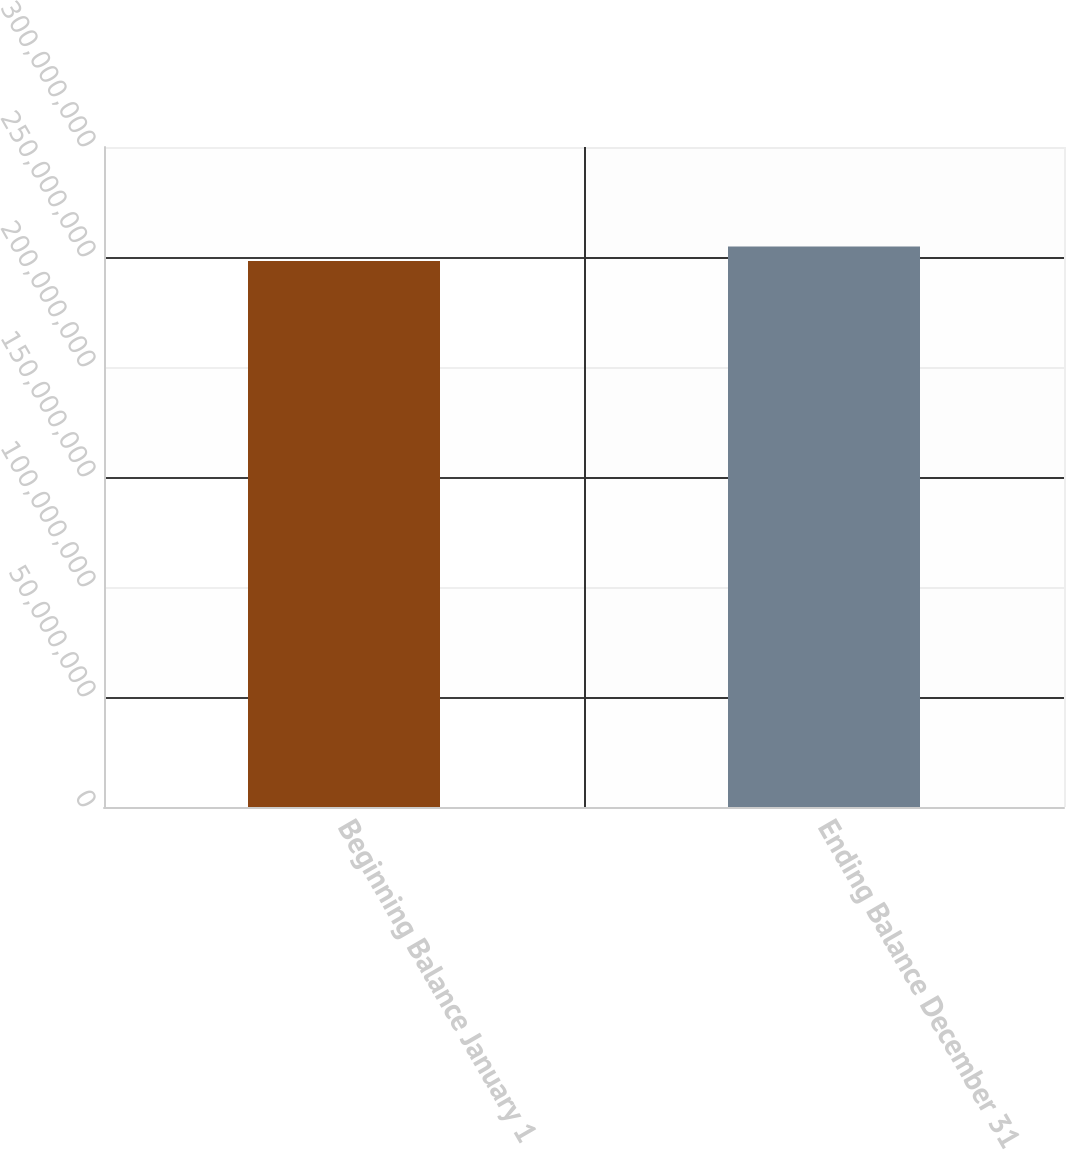Convert chart. <chart><loc_0><loc_0><loc_500><loc_500><bar_chart><fcel>Beginning Balance January 1<fcel>Ending Balance December 31<nl><fcel>2.48174e+08<fcel>2.54753e+08<nl></chart> 